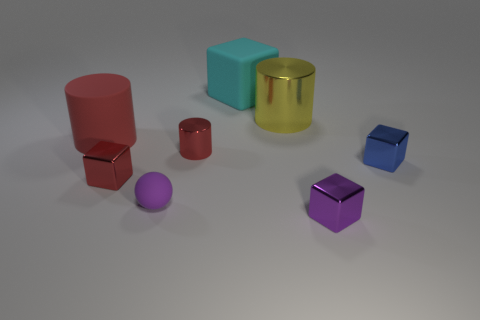Add 1 blue blocks. How many objects exist? 9 Subtract all balls. How many objects are left? 7 Subtract 0 brown cylinders. How many objects are left? 8 Subtract all small yellow rubber balls. Subtract all red metallic cylinders. How many objects are left? 7 Add 5 tiny red cylinders. How many tiny red cylinders are left? 6 Add 8 big cylinders. How many big cylinders exist? 10 